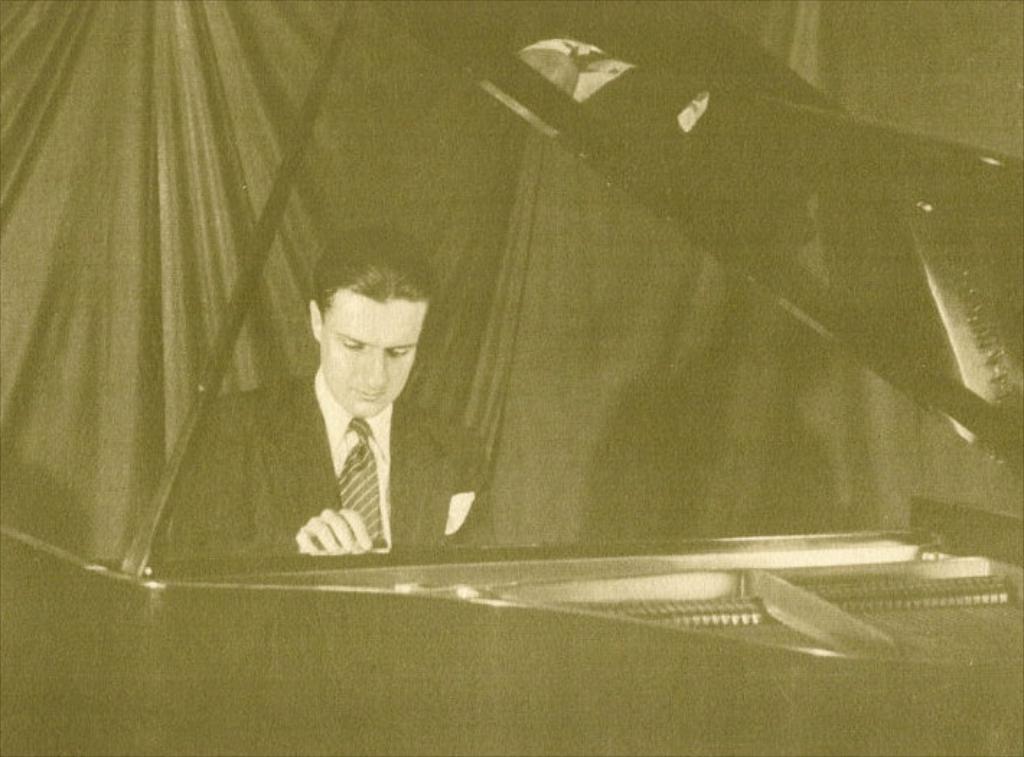How would you summarize this image in a sentence or two? This is a black and white picture. In this picture there is a person sitting in front of a piano. In the background there is curtain. 